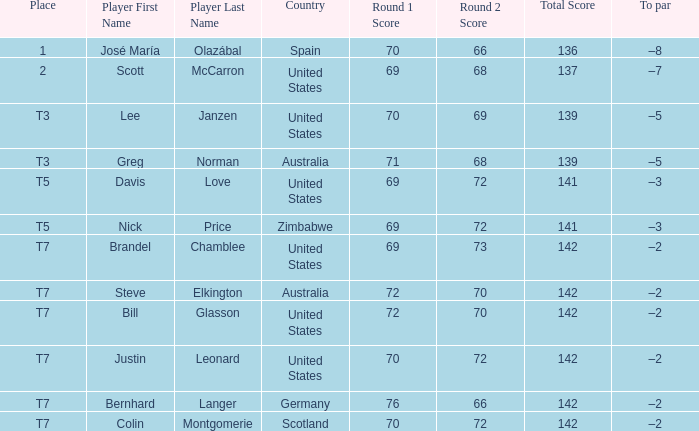Name the Player who has a Place of t7 in Country of united states? Brandel Chamblee, Bill Glasson, Justin Leonard. 